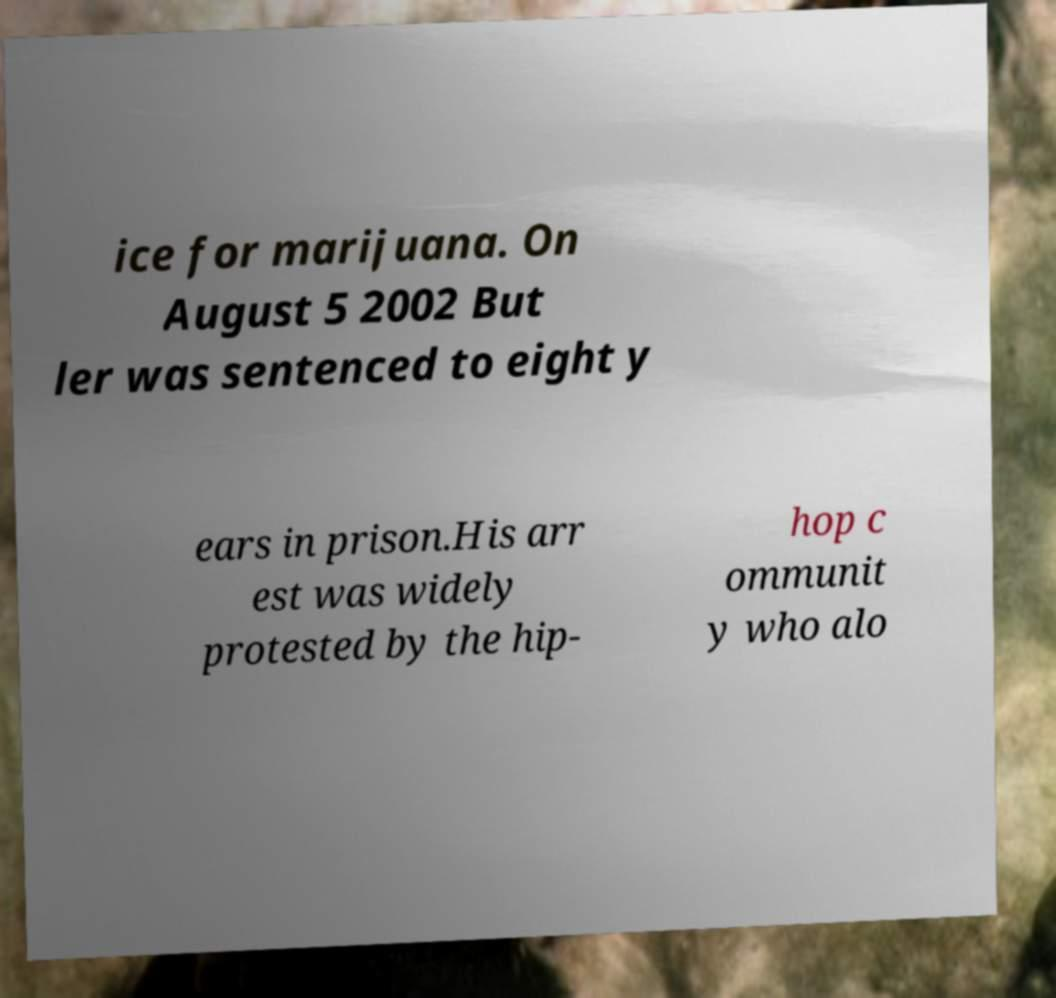Can you read and provide the text displayed in the image?This photo seems to have some interesting text. Can you extract and type it out for me? ice for marijuana. On August 5 2002 But ler was sentenced to eight y ears in prison.His arr est was widely protested by the hip- hop c ommunit y who alo 